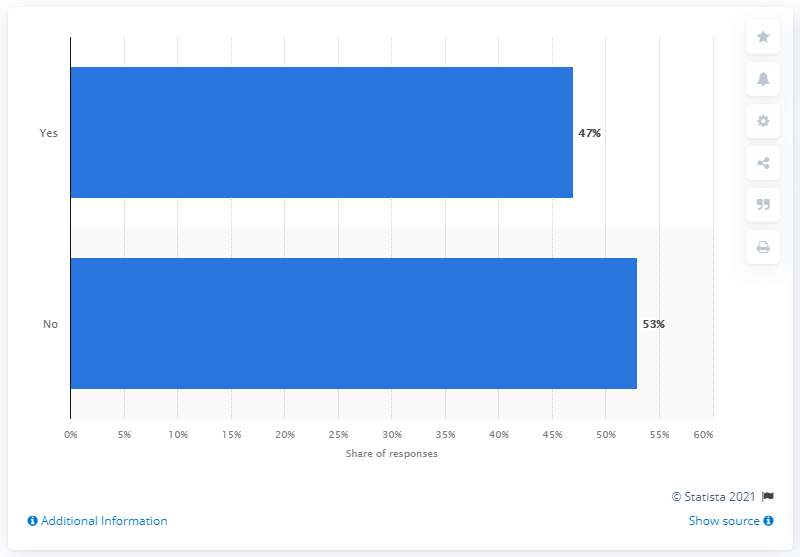Give some essential details in this illustration. The ratio of "No" to "Yes" is approximately 1.127659574... 